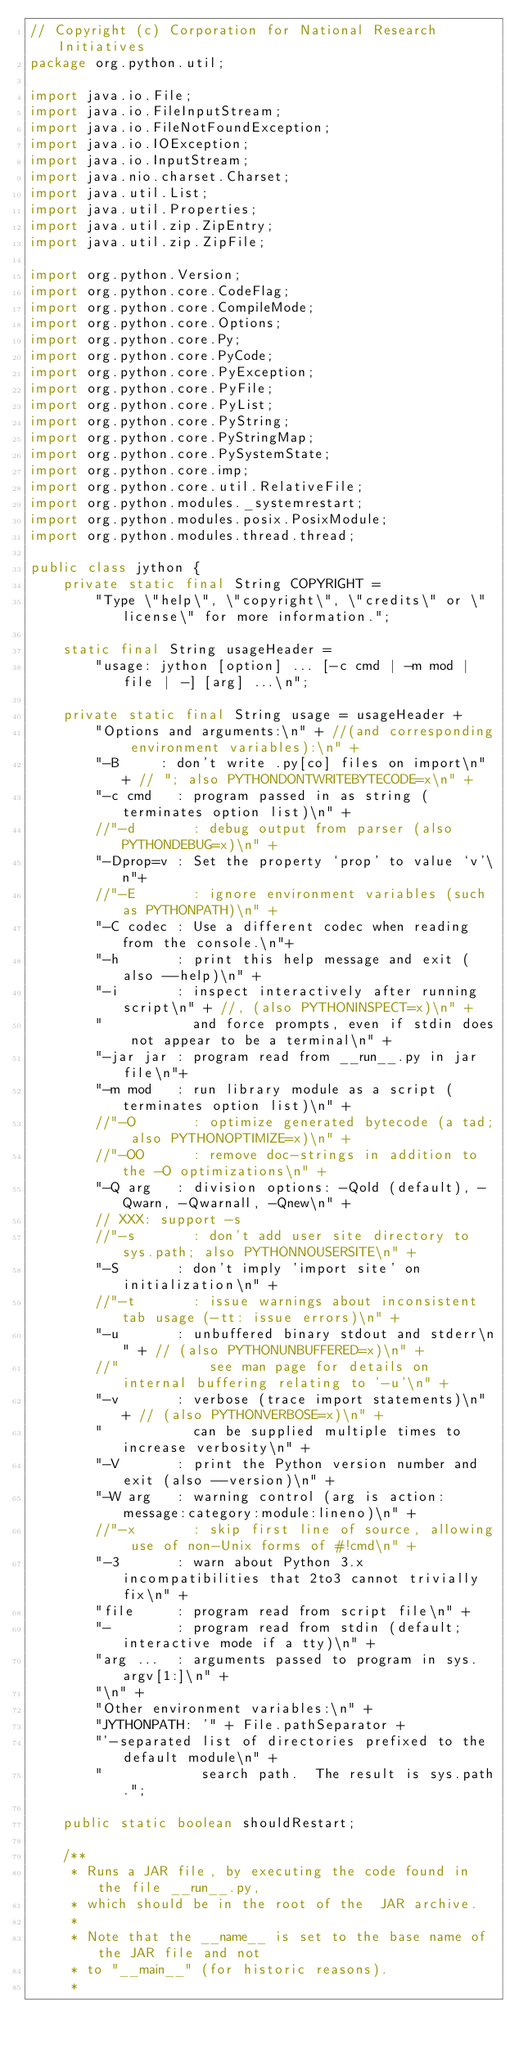<code> <loc_0><loc_0><loc_500><loc_500><_Java_>// Copyright (c) Corporation for National Research Initiatives
package org.python.util;

import java.io.File;
import java.io.FileInputStream;
import java.io.FileNotFoundException;
import java.io.IOException;
import java.io.InputStream;
import java.nio.charset.Charset;
import java.util.List;
import java.util.Properties;
import java.util.zip.ZipEntry;
import java.util.zip.ZipFile;

import org.python.Version;
import org.python.core.CodeFlag;
import org.python.core.CompileMode;
import org.python.core.Options;
import org.python.core.Py;
import org.python.core.PyCode;
import org.python.core.PyException;
import org.python.core.PyFile;
import org.python.core.PyList;
import org.python.core.PyString;
import org.python.core.PyStringMap;
import org.python.core.PySystemState;
import org.python.core.imp;
import org.python.core.util.RelativeFile;
import org.python.modules._systemrestart;
import org.python.modules.posix.PosixModule;
import org.python.modules.thread.thread;

public class jython {
    private static final String COPYRIGHT =
        "Type \"help\", \"copyright\", \"credits\" or \"license\" for more information.";

    static final String usageHeader =
        "usage: jython [option] ... [-c cmd | -m mod | file | -] [arg] ...\n";

    private static final String usage = usageHeader +
        "Options and arguments:\n" + //(and corresponding environment variables):\n" +
        "-B     : don't write .py[co] files on import\n" + // "; also PYTHONDONTWRITEBYTECODE=x\n" +
        "-c cmd   : program passed in as string (terminates option list)\n" +
        //"-d       : debug output from parser (also PYTHONDEBUG=x)\n" +
        "-Dprop=v : Set the property `prop' to value `v'\n"+
        //"-E       : ignore environment variables (such as PYTHONPATH)\n" +
        "-C codec : Use a different codec when reading from the console.\n"+
        "-h       : print this help message and exit (also --help)\n" +
        "-i       : inspect interactively after running script\n" + //, (also PYTHONINSPECT=x)\n" +
        "           and force prompts, even if stdin does not appear to be a terminal\n" +
        "-jar jar : program read from __run__.py in jar file\n"+
        "-m mod   : run library module as a script (terminates option list)\n" +
        //"-O       : optimize generated bytecode (a tad; also PYTHONOPTIMIZE=x)\n" +
        //"-OO      : remove doc-strings in addition to the -O optimizations\n" +
        "-Q arg   : division options: -Qold (default), -Qwarn, -Qwarnall, -Qnew\n" +
        // XXX: support -s
        //"-s       : don't add user site directory to sys.path; also PYTHONNOUSERSITE\n" +
        "-S       : don't imply 'import site' on initialization\n" +
        //"-t       : issue warnings about inconsistent tab usage (-tt: issue errors)\n" +
        "-u       : unbuffered binary stdout and stderr\n" + // (also PYTHONUNBUFFERED=x)\n" +
        //"           see man page for details on internal buffering relating to '-u'\n" +
        "-v       : verbose (trace import statements)\n" + // (also PYTHONVERBOSE=x)\n" +
        "           can be supplied multiple times to increase verbosity\n" +
        "-V       : print the Python version number and exit (also --version)\n" +
        "-W arg   : warning control (arg is action:message:category:module:lineno)\n" +
        //"-x       : skip first line of source, allowing use of non-Unix forms of #!cmd\n" +
        "-3       : warn about Python 3.x incompatibilities that 2to3 cannot trivially fix\n" +
        "file     : program read from script file\n" +
        "-        : program read from stdin (default; interactive mode if a tty)\n" +
        "arg ...  : arguments passed to program in sys.argv[1:]\n" +
        "\n" +
        "Other environment variables:\n" +
        "JYTHONPATH: '" + File.pathSeparator +
        "'-separated list of directories prefixed to the default module\n" +
        "            search path.  The result is sys.path.";

    public static boolean shouldRestart;

    /**
     * Runs a JAR file, by executing the code found in the file __run__.py, 
     * which should be in the root of the  JAR archive. 
     * 
     * Note that the __name__ is set to the base name of the JAR file and not 
     * to "__main__" (for historic reasons). 
     * </code> 